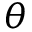<formula> <loc_0><loc_0><loc_500><loc_500>\theta</formula> 